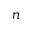<formula> <loc_0><loc_0><loc_500><loc_500>n</formula> 